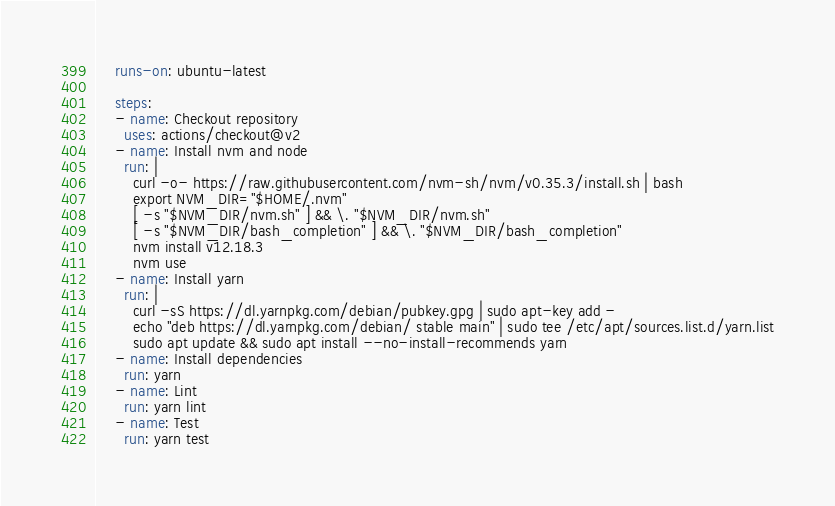<code> <loc_0><loc_0><loc_500><loc_500><_YAML_>    runs-on: ubuntu-latest

    steps:
    - name: Checkout repository
      uses: actions/checkout@v2
    - name: Install nvm and node
      run: |
        curl -o- https://raw.githubusercontent.com/nvm-sh/nvm/v0.35.3/install.sh | bash
        export NVM_DIR="$HOME/.nvm"
        [ -s "$NVM_DIR/nvm.sh" ] && \. "$NVM_DIR/nvm.sh"
        [ -s "$NVM_DIR/bash_completion" ] && \. "$NVM_DIR/bash_completion"
        nvm install v12.18.3
        nvm use
    - name: Install yarn
      run: |
        curl -sS https://dl.yarnpkg.com/debian/pubkey.gpg | sudo apt-key add -
        echo "deb https://dl.yarnpkg.com/debian/ stable main" | sudo tee /etc/apt/sources.list.d/yarn.list
        sudo apt update && sudo apt install --no-install-recommends yarn
    - name: Install dependencies
      run: yarn
    - name: Lint
      run: yarn lint
    - name: Test
      run: yarn test
</code> 